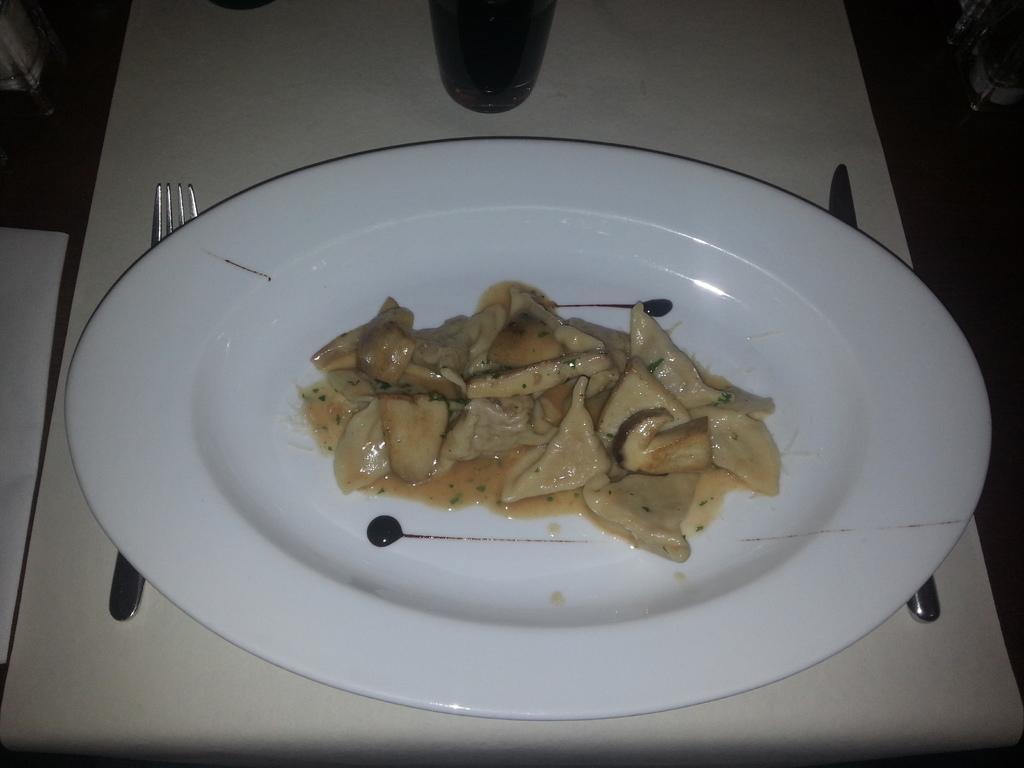Describe this image in one or two sentences. In this image there is a table. There is a plate, glass, fork, knife on the table. Few objects are on the table. There is some food in the plate. 